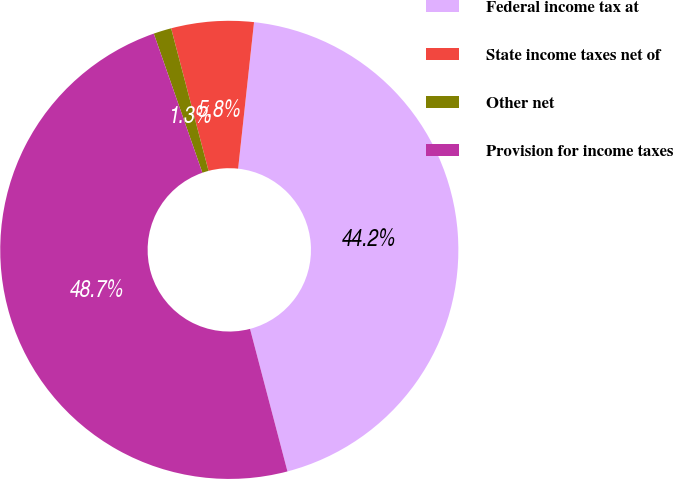Convert chart to OTSL. <chart><loc_0><loc_0><loc_500><loc_500><pie_chart><fcel>Federal income tax at<fcel>State income taxes net of<fcel>Other net<fcel>Provision for income taxes<nl><fcel>44.19%<fcel>5.81%<fcel>1.26%<fcel>48.74%<nl></chart> 